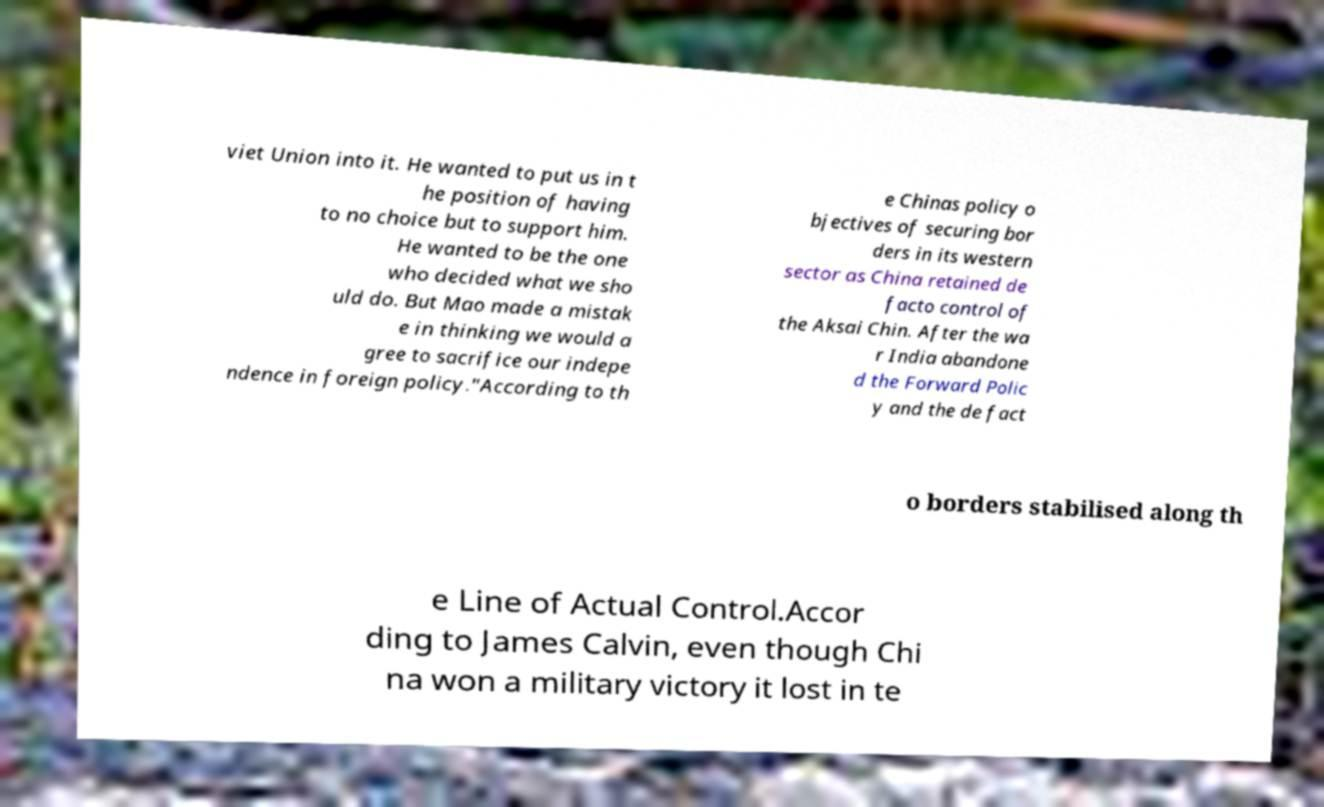Please read and relay the text visible in this image. What does it say? viet Union into it. He wanted to put us in t he position of having to no choice but to support him. He wanted to be the one who decided what we sho uld do. But Mao made a mistak e in thinking we would a gree to sacrifice our indepe ndence in foreign policy."According to th e Chinas policy o bjectives of securing bor ders in its western sector as China retained de facto control of the Aksai Chin. After the wa r India abandone d the Forward Polic y and the de fact o borders stabilised along th e Line of Actual Control.Accor ding to James Calvin, even though Chi na won a military victory it lost in te 